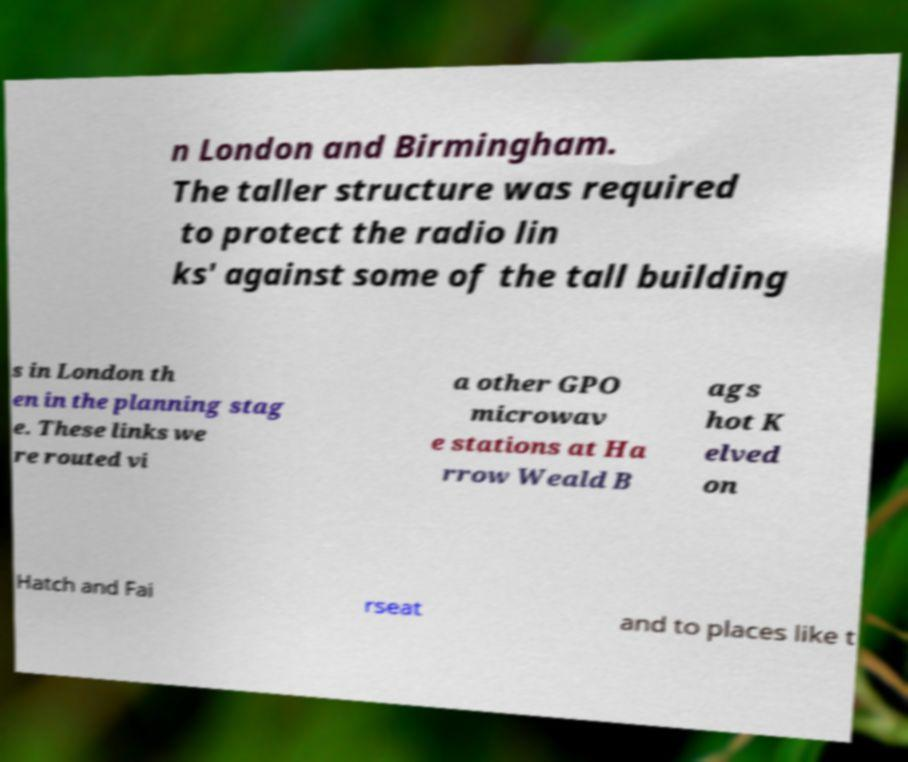Please read and relay the text visible in this image. What does it say? n London and Birmingham. The taller structure was required to protect the radio lin ks' against some of the tall building s in London th en in the planning stag e. These links we re routed vi a other GPO microwav e stations at Ha rrow Weald B ags hot K elved on Hatch and Fai rseat and to places like t 